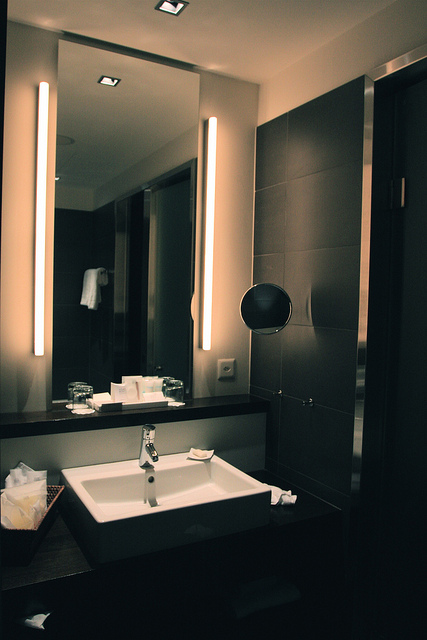Imagine a scenario where the lighting in the bathroom is suddenly turned off. How does the ambiance and functionality of the space change? If the lighting in the bathroom were suddenly turned off, the ambiance would shift dramatically from warm and inviting to potentially unsettling. The dark tiles and closed space might create a claustrophobic feel. Functionality would be greatly compromised, making it difficult to use the sink, mirrors, or any other utility. The sophisticated modern design relies heavily on proper lighting to highlight its features, without which the space would lose much of its elegance and practicality.  Imagine this bathroom is situated in a futuristic space station. How would that context change the details and objects present in the image? In a futuristic space station, this bathroom might incorporate advanced technology and materials. The sink could have touchless operation with water that is treated and recycled on-site. The mirror might double as an interactive smart display, providing real-time information or entertainment. The materials could be ultra-light and resilient, adapted to low gravity conditions. The soap dispensers might release a quick-drying, sanitizing foam rather than traditional soap and water, considering water conservation in space. Additionally, the ventilation system would be designed to effectively manage air quality in the enclosed station environment, perhaps featuring advanced air purification technologies. This context would transform the bathroom into a high-tech, multifunctional space integral to life aboard the station. 